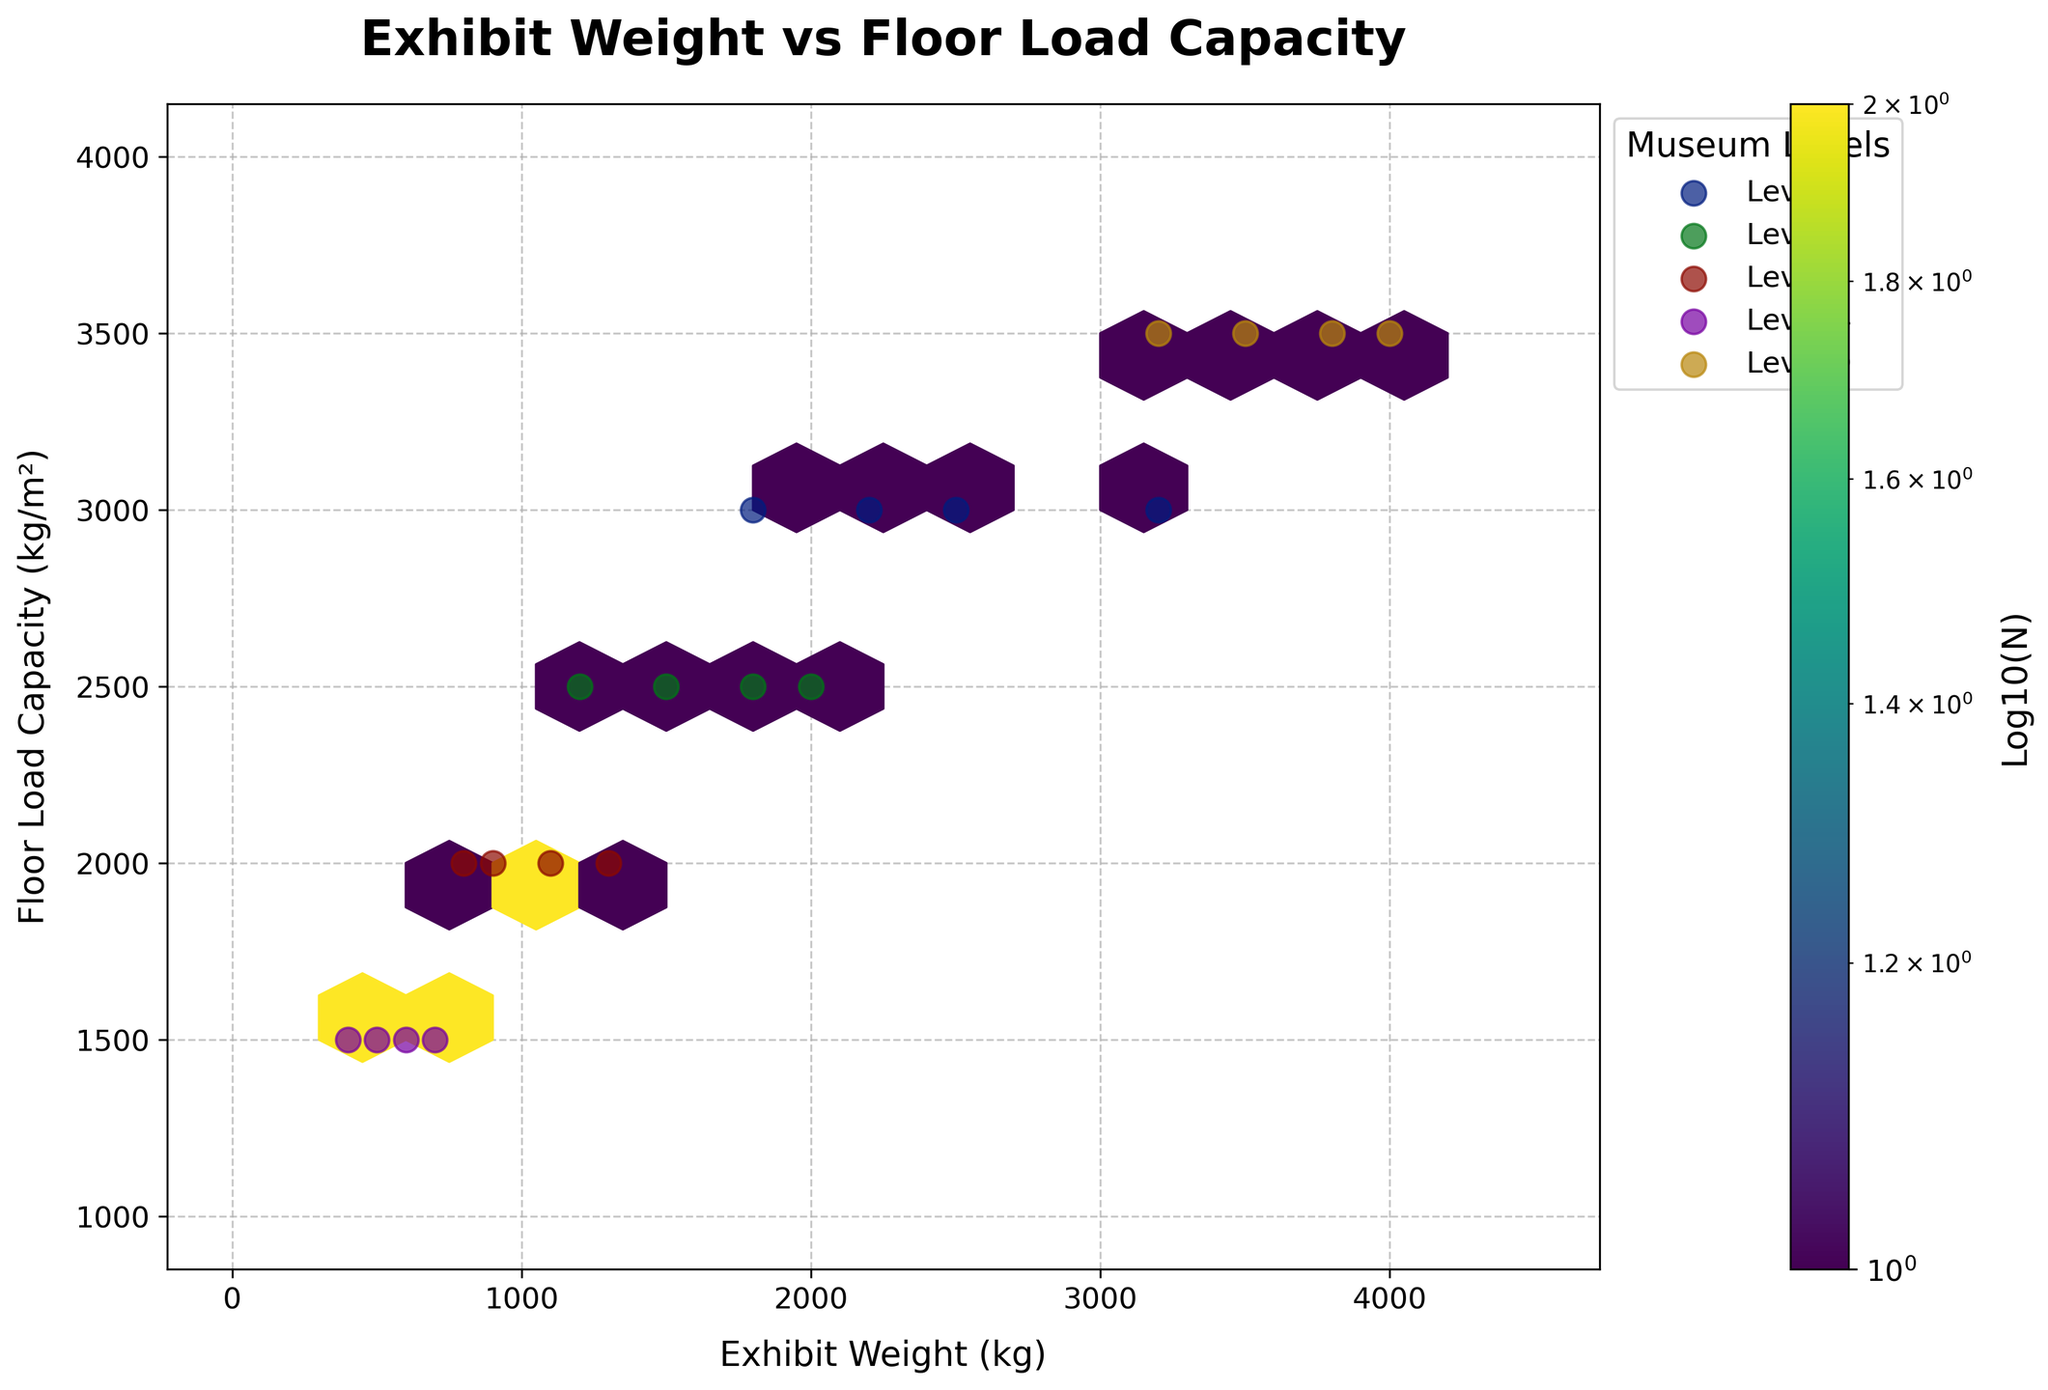How many museum levels are represented in the plot? Identify the unique levels listed in the legend which corresponds to the museum levels
Answer: 5 What's the color of the hexagons? Observe the color map used for the hexbin plot. The hexagons are primarily shaded in green, corresponding to the viridis colormap
Answer: Green What does the color intensity in the hexagon represent? Notice the color bar on the right side of the plot, which indicates that color intensity represents the log scale of the number of points (Log10(N))
Answer: Log scale of number of points Which museum level has exhibits with the highest floor load capacity? Look at the level indicators and identify which level has points at the highest y-axis value (3500 kg/m²)
Answer: Level 0 Are there any museum levels where the exhibit weights range above 3000 kg? Examine the scatter points for each level; Levels 0 and 1 have exhibit weights above 3000 kg
Answer: Yes What's the title of the plot? Refer to the top center of the plot
Answer: Exhibit Weight vs Floor Load Capacity How many levels have a floor load capacity of 1500 kg/m²? Count the different colored scatter points horizontally aligned at 1500 kg/m²
Answer: 2 (Levels 4 and 2) Compare the exhibit weights for Level 2 and Level 3. Which level generally has heavier exhibits? Observe the scatter points for Levels 2 and 3. Level 2's weights go up to 2000 kg, while Level 3's go up to 1300 kg
Answer: Level 2 On which axis is the floor load capacity measured? Look at the axis labels to determine where the floor load capacity is indicated
Answer: Y-axis Why is the hexbin plot useful for this data? Interpret the purpose of hexbin plots, which aggregate data points into hexagons, making it easier to visualize density and correlation in large datasets
Answer: Illustrates density and correlation of large datasets 